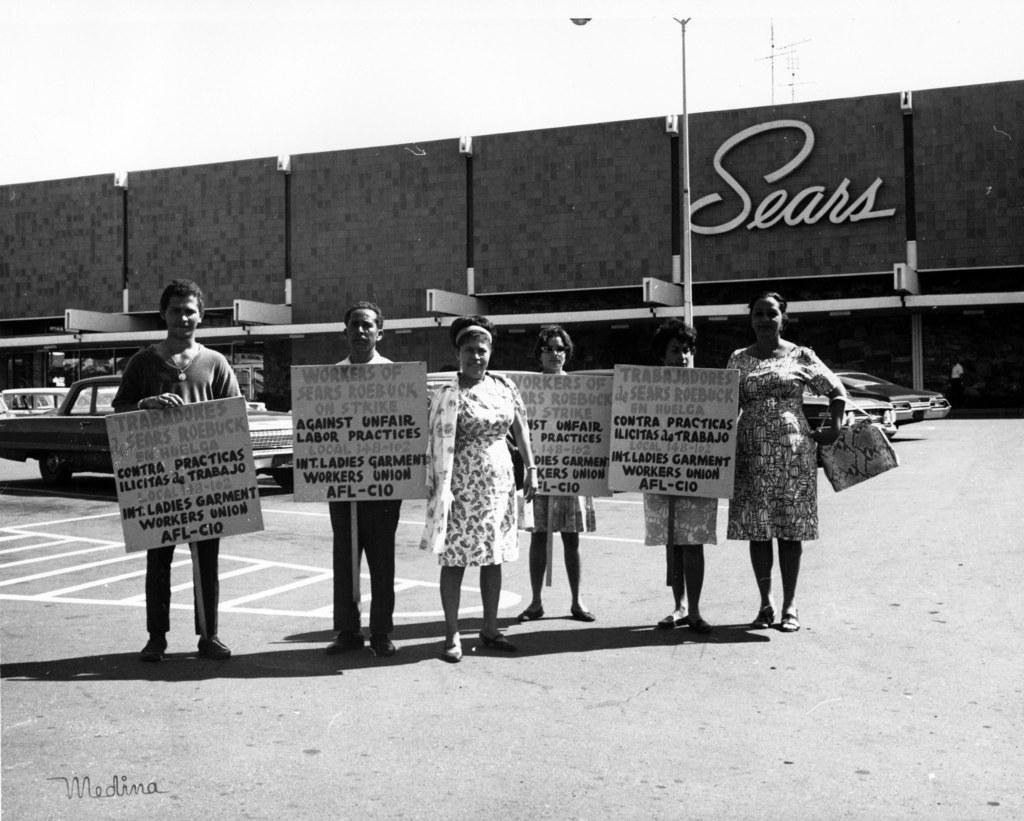How many people are in the image? There are six persons in the image. What are four of the persons doing in the image? Four of the persons are holding boards with their hands. What can be seen in the background of the image? There is a road, cars, a pole, a building, and the sky visible in the background. How does friction affect the movement of the rabbits in the image? There are no rabbits present in the image, so friction does not affect their movement. What type of owl can be seen perched on the pole in the image? There is no owl present in the image; only a pole is visible in the background. 